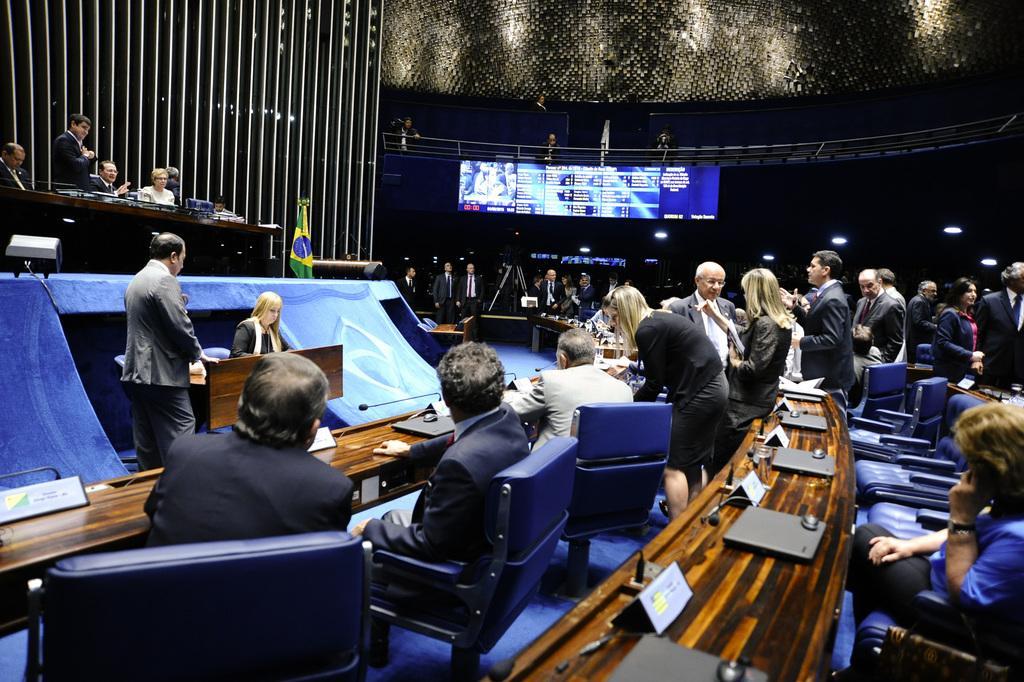Could you give a brief overview of what you see in this image? This image is clicked in a conference hall. To the left, there is a table on the dais. To the right, the woman sitting is wearing a blue shirt. In the front, there is a table on which there are laptops along with mouse. In the background, there is a screen changed to a stand. 